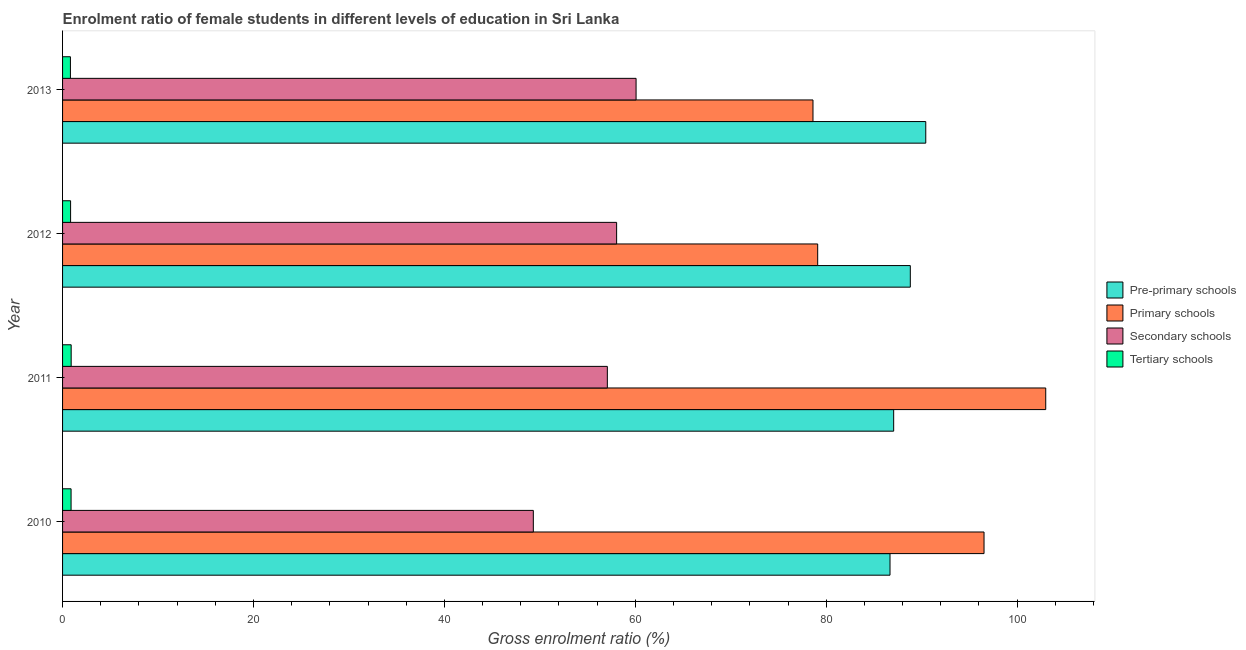Are the number of bars per tick equal to the number of legend labels?
Your answer should be very brief. Yes. How many bars are there on the 4th tick from the top?
Give a very brief answer. 4. What is the label of the 4th group of bars from the top?
Give a very brief answer. 2010. In how many cases, is the number of bars for a given year not equal to the number of legend labels?
Provide a succinct answer. 0. What is the gross enrolment ratio(male) in primary schools in 2010?
Offer a terse response. 96.53. Across all years, what is the maximum gross enrolment ratio(male) in secondary schools?
Make the answer very short. 60.08. Across all years, what is the minimum gross enrolment ratio(male) in primary schools?
Your response must be concise. 78.61. In which year was the gross enrolment ratio(male) in secondary schools maximum?
Provide a short and direct response. 2013. What is the total gross enrolment ratio(male) in primary schools in the graph?
Your response must be concise. 357.26. What is the difference between the gross enrolment ratio(male) in secondary schools in 2011 and that in 2012?
Make the answer very short. -0.97. What is the difference between the gross enrolment ratio(male) in secondary schools in 2010 and the gross enrolment ratio(male) in pre-primary schools in 2013?
Make the answer very short. -41.11. What is the average gross enrolment ratio(male) in tertiary schools per year?
Ensure brevity in your answer.  0.86. In the year 2010, what is the difference between the gross enrolment ratio(male) in tertiary schools and gross enrolment ratio(male) in pre-primary schools?
Your answer should be very brief. -85.79. What is the ratio of the gross enrolment ratio(male) in primary schools in 2010 to that in 2012?
Your answer should be very brief. 1.22. What is the difference between the highest and the second highest gross enrolment ratio(male) in tertiary schools?
Give a very brief answer. 0.01. What is the difference between the highest and the lowest gross enrolment ratio(male) in primary schools?
Keep it short and to the point. 24.38. In how many years, is the gross enrolment ratio(male) in tertiary schools greater than the average gross enrolment ratio(male) in tertiary schools taken over all years?
Offer a very short reply. 2. Is it the case that in every year, the sum of the gross enrolment ratio(male) in pre-primary schools and gross enrolment ratio(male) in tertiary schools is greater than the sum of gross enrolment ratio(male) in secondary schools and gross enrolment ratio(male) in primary schools?
Provide a short and direct response. No. What does the 2nd bar from the top in 2010 represents?
Provide a succinct answer. Secondary schools. What does the 1st bar from the bottom in 2011 represents?
Offer a very short reply. Pre-primary schools. Is it the case that in every year, the sum of the gross enrolment ratio(male) in pre-primary schools and gross enrolment ratio(male) in primary schools is greater than the gross enrolment ratio(male) in secondary schools?
Offer a terse response. Yes. What is the difference between two consecutive major ticks on the X-axis?
Give a very brief answer. 20. Does the graph contain grids?
Your response must be concise. No. Where does the legend appear in the graph?
Make the answer very short. Center right. What is the title of the graph?
Provide a succinct answer. Enrolment ratio of female students in different levels of education in Sri Lanka. Does "UNDP" appear as one of the legend labels in the graph?
Offer a very short reply. No. What is the label or title of the Y-axis?
Ensure brevity in your answer.  Year. What is the Gross enrolment ratio (%) of Pre-primary schools in 2010?
Your answer should be very brief. 86.68. What is the Gross enrolment ratio (%) of Primary schools in 2010?
Keep it short and to the point. 96.53. What is the Gross enrolment ratio (%) of Secondary schools in 2010?
Make the answer very short. 49.32. What is the Gross enrolment ratio (%) in Tertiary schools in 2010?
Offer a very short reply. 0.89. What is the Gross enrolment ratio (%) in Pre-primary schools in 2011?
Your answer should be compact. 87.07. What is the Gross enrolment ratio (%) of Primary schools in 2011?
Make the answer very short. 103. What is the Gross enrolment ratio (%) in Secondary schools in 2011?
Make the answer very short. 57.07. What is the Gross enrolment ratio (%) in Tertiary schools in 2011?
Provide a succinct answer. 0.9. What is the Gross enrolment ratio (%) in Pre-primary schools in 2012?
Your response must be concise. 88.81. What is the Gross enrolment ratio (%) of Primary schools in 2012?
Offer a terse response. 79.11. What is the Gross enrolment ratio (%) of Secondary schools in 2012?
Give a very brief answer. 58.04. What is the Gross enrolment ratio (%) in Tertiary schools in 2012?
Give a very brief answer. 0.84. What is the Gross enrolment ratio (%) of Pre-primary schools in 2013?
Provide a short and direct response. 90.43. What is the Gross enrolment ratio (%) in Primary schools in 2013?
Offer a very short reply. 78.61. What is the Gross enrolment ratio (%) of Secondary schools in 2013?
Keep it short and to the point. 60.08. What is the Gross enrolment ratio (%) of Tertiary schools in 2013?
Your answer should be compact. 0.82. Across all years, what is the maximum Gross enrolment ratio (%) of Pre-primary schools?
Ensure brevity in your answer.  90.43. Across all years, what is the maximum Gross enrolment ratio (%) in Primary schools?
Your response must be concise. 103. Across all years, what is the maximum Gross enrolment ratio (%) of Secondary schools?
Ensure brevity in your answer.  60.08. Across all years, what is the maximum Gross enrolment ratio (%) in Tertiary schools?
Offer a very short reply. 0.9. Across all years, what is the minimum Gross enrolment ratio (%) of Pre-primary schools?
Ensure brevity in your answer.  86.68. Across all years, what is the minimum Gross enrolment ratio (%) in Primary schools?
Provide a succinct answer. 78.61. Across all years, what is the minimum Gross enrolment ratio (%) in Secondary schools?
Your response must be concise. 49.32. Across all years, what is the minimum Gross enrolment ratio (%) of Tertiary schools?
Give a very brief answer. 0.82. What is the total Gross enrolment ratio (%) of Pre-primary schools in the graph?
Your answer should be compact. 352.99. What is the total Gross enrolment ratio (%) of Primary schools in the graph?
Your response must be concise. 357.25. What is the total Gross enrolment ratio (%) of Secondary schools in the graph?
Offer a terse response. 224.52. What is the total Gross enrolment ratio (%) in Tertiary schools in the graph?
Offer a terse response. 3.46. What is the difference between the Gross enrolment ratio (%) of Pre-primary schools in 2010 and that in 2011?
Offer a very short reply. -0.38. What is the difference between the Gross enrolment ratio (%) of Primary schools in 2010 and that in 2011?
Make the answer very short. -6.46. What is the difference between the Gross enrolment ratio (%) in Secondary schools in 2010 and that in 2011?
Your response must be concise. -7.75. What is the difference between the Gross enrolment ratio (%) in Tertiary schools in 2010 and that in 2011?
Offer a very short reply. -0.01. What is the difference between the Gross enrolment ratio (%) in Pre-primary schools in 2010 and that in 2012?
Your answer should be very brief. -2.13. What is the difference between the Gross enrolment ratio (%) of Primary schools in 2010 and that in 2012?
Your answer should be very brief. 17.43. What is the difference between the Gross enrolment ratio (%) in Secondary schools in 2010 and that in 2012?
Your response must be concise. -8.73. What is the difference between the Gross enrolment ratio (%) of Tertiary schools in 2010 and that in 2012?
Ensure brevity in your answer.  0.05. What is the difference between the Gross enrolment ratio (%) of Pre-primary schools in 2010 and that in 2013?
Ensure brevity in your answer.  -3.75. What is the difference between the Gross enrolment ratio (%) of Primary schools in 2010 and that in 2013?
Your response must be concise. 17.92. What is the difference between the Gross enrolment ratio (%) in Secondary schools in 2010 and that in 2013?
Make the answer very short. -10.76. What is the difference between the Gross enrolment ratio (%) in Tertiary schools in 2010 and that in 2013?
Give a very brief answer. 0.07. What is the difference between the Gross enrolment ratio (%) of Pre-primary schools in 2011 and that in 2012?
Your response must be concise. -1.74. What is the difference between the Gross enrolment ratio (%) in Primary schools in 2011 and that in 2012?
Your answer should be compact. 23.89. What is the difference between the Gross enrolment ratio (%) of Secondary schools in 2011 and that in 2012?
Ensure brevity in your answer.  -0.97. What is the difference between the Gross enrolment ratio (%) of Tertiary schools in 2011 and that in 2012?
Give a very brief answer. 0.06. What is the difference between the Gross enrolment ratio (%) in Pre-primary schools in 2011 and that in 2013?
Give a very brief answer. -3.36. What is the difference between the Gross enrolment ratio (%) in Primary schools in 2011 and that in 2013?
Make the answer very short. 24.38. What is the difference between the Gross enrolment ratio (%) in Secondary schools in 2011 and that in 2013?
Provide a short and direct response. -3.01. What is the difference between the Gross enrolment ratio (%) in Tertiary schools in 2011 and that in 2013?
Make the answer very short. 0.08. What is the difference between the Gross enrolment ratio (%) of Pre-primary schools in 2012 and that in 2013?
Offer a very short reply. -1.62. What is the difference between the Gross enrolment ratio (%) of Primary schools in 2012 and that in 2013?
Your answer should be compact. 0.49. What is the difference between the Gross enrolment ratio (%) in Secondary schools in 2012 and that in 2013?
Keep it short and to the point. -2.04. What is the difference between the Gross enrolment ratio (%) in Tertiary schools in 2012 and that in 2013?
Offer a very short reply. 0.02. What is the difference between the Gross enrolment ratio (%) in Pre-primary schools in 2010 and the Gross enrolment ratio (%) in Primary schools in 2011?
Your response must be concise. -16.31. What is the difference between the Gross enrolment ratio (%) in Pre-primary schools in 2010 and the Gross enrolment ratio (%) in Secondary schools in 2011?
Provide a short and direct response. 29.61. What is the difference between the Gross enrolment ratio (%) in Pre-primary schools in 2010 and the Gross enrolment ratio (%) in Tertiary schools in 2011?
Keep it short and to the point. 85.78. What is the difference between the Gross enrolment ratio (%) in Primary schools in 2010 and the Gross enrolment ratio (%) in Secondary schools in 2011?
Your answer should be very brief. 39.46. What is the difference between the Gross enrolment ratio (%) of Primary schools in 2010 and the Gross enrolment ratio (%) of Tertiary schools in 2011?
Make the answer very short. 95.63. What is the difference between the Gross enrolment ratio (%) of Secondary schools in 2010 and the Gross enrolment ratio (%) of Tertiary schools in 2011?
Your answer should be very brief. 48.42. What is the difference between the Gross enrolment ratio (%) in Pre-primary schools in 2010 and the Gross enrolment ratio (%) in Primary schools in 2012?
Provide a succinct answer. 7.58. What is the difference between the Gross enrolment ratio (%) in Pre-primary schools in 2010 and the Gross enrolment ratio (%) in Secondary schools in 2012?
Give a very brief answer. 28.64. What is the difference between the Gross enrolment ratio (%) in Pre-primary schools in 2010 and the Gross enrolment ratio (%) in Tertiary schools in 2012?
Your answer should be very brief. 85.84. What is the difference between the Gross enrolment ratio (%) of Primary schools in 2010 and the Gross enrolment ratio (%) of Secondary schools in 2012?
Offer a terse response. 38.49. What is the difference between the Gross enrolment ratio (%) in Primary schools in 2010 and the Gross enrolment ratio (%) in Tertiary schools in 2012?
Provide a succinct answer. 95.69. What is the difference between the Gross enrolment ratio (%) in Secondary schools in 2010 and the Gross enrolment ratio (%) in Tertiary schools in 2012?
Ensure brevity in your answer.  48.48. What is the difference between the Gross enrolment ratio (%) of Pre-primary schools in 2010 and the Gross enrolment ratio (%) of Primary schools in 2013?
Ensure brevity in your answer.  8.07. What is the difference between the Gross enrolment ratio (%) of Pre-primary schools in 2010 and the Gross enrolment ratio (%) of Secondary schools in 2013?
Ensure brevity in your answer.  26.6. What is the difference between the Gross enrolment ratio (%) in Pre-primary schools in 2010 and the Gross enrolment ratio (%) in Tertiary schools in 2013?
Provide a short and direct response. 85.86. What is the difference between the Gross enrolment ratio (%) of Primary schools in 2010 and the Gross enrolment ratio (%) of Secondary schools in 2013?
Your response must be concise. 36.45. What is the difference between the Gross enrolment ratio (%) of Primary schools in 2010 and the Gross enrolment ratio (%) of Tertiary schools in 2013?
Make the answer very short. 95.71. What is the difference between the Gross enrolment ratio (%) in Secondary schools in 2010 and the Gross enrolment ratio (%) in Tertiary schools in 2013?
Make the answer very short. 48.49. What is the difference between the Gross enrolment ratio (%) of Pre-primary schools in 2011 and the Gross enrolment ratio (%) of Primary schools in 2012?
Your response must be concise. 7.96. What is the difference between the Gross enrolment ratio (%) in Pre-primary schools in 2011 and the Gross enrolment ratio (%) in Secondary schools in 2012?
Offer a terse response. 29.02. What is the difference between the Gross enrolment ratio (%) in Pre-primary schools in 2011 and the Gross enrolment ratio (%) in Tertiary schools in 2012?
Your response must be concise. 86.23. What is the difference between the Gross enrolment ratio (%) in Primary schools in 2011 and the Gross enrolment ratio (%) in Secondary schools in 2012?
Your answer should be very brief. 44.95. What is the difference between the Gross enrolment ratio (%) in Primary schools in 2011 and the Gross enrolment ratio (%) in Tertiary schools in 2012?
Provide a succinct answer. 102.16. What is the difference between the Gross enrolment ratio (%) in Secondary schools in 2011 and the Gross enrolment ratio (%) in Tertiary schools in 2012?
Offer a terse response. 56.23. What is the difference between the Gross enrolment ratio (%) of Pre-primary schools in 2011 and the Gross enrolment ratio (%) of Primary schools in 2013?
Ensure brevity in your answer.  8.45. What is the difference between the Gross enrolment ratio (%) in Pre-primary schools in 2011 and the Gross enrolment ratio (%) in Secondary schools in 2013?
Keep it short and to the point. 26.99. What is the difference between the Gross enrolment ratio (%) in Pre-primary schools in 2011 and the Gross enrolment ratio (%) in Tertiary schools in 2013?
Make the answer very short. 86.25. What is the difference between the Gross enrolment ratio (%) in Primary schools in 2011 and the Gross enrolment ratio (%) in Secondary schools in 2013?
Offer a very short reply. 42.92. What is the difference between the Gross enrolment ratio (%) in Primary schools in 2011 and the Gross enrolment ratio (%) in Tertiary schools in 2013?
Give a very brief answer. 102.18. What is the difference between the Gross enrolment ratio (%) in Secondary schools in 2011 and the Gross enrolment ratio (%) in Tertiary schools in 2013?
Provide a short and direct response. 56.25. What is the difference between the Gross enrolment ratio (%) in Pre-primary schools in 2012 and the Gross enrolment ratio (%) in Primary schools in 2013?
Offer a very short reply. 10.2. What is the difference between the Gross enrolment ratio (%) in Pre-primary schools in 2012 and the Gross enrolment ratio (%) in Secondary schools in 2013?
Make the answer very short. 28.73. What is the difference between the Gross enrolment ratio (%) in Pre-primary schools in 2012 and the Gross enrolment ratio (%) in Tertiary schools in 2013?
Provide a short and direct response. 87.99. What is the difference between the Gross enrolment ratio (%) in Primary schools in 2012 and the Gross enrolment ratio (%) in Secondary schools in 2013?
Provide a short and direct response. 19.03. What is the difference between the Gross enrolment ratio (%) of Primary schools in 2012 and the Gross enrolment ratio (%) of Tertiary schools in 2013?
Offer a very short reply. 78.29. What is the difference between the Gross enrolment ratio (%) in Secondary schools in 2012 and the Gross enrolment ratio (%) in Tertiary schools in 2013?
Your answer should be very brief. 57.22. What is the average Gross enrolment ratio (%) of Pre-primary schools per year?
Ensure brevity in your answer.  88.25. What is the average Gross enrolment ratio (%) in Primary schools per year?
Offer a very short reply. 89.31. What is the average Gross enrolment ratio (%) in Secondary schools per year?
Provide a short and direct response. 56.13. What is the average Gross enrolment ratio (%) of Tertiary schools per year?
Ensure brevity in your answer.  0.86. In the year 2010, what is the difference between the Gross enrolment ratio (%) of Pre-primary schools and Gross enrolment ratio (%) of Primary schools?
Your answer should be compact. -9.85. In the year 2010, what is the difference between the Gross enrolment ratio (%) in Pre-primary schools and Gross enrolment ratio (%) in Secondary schools?
Give a very brief answer. 37.37. In the year 2010, what is the difference between the Gross enrolment ratio (%) in Pre-primary schools and Gross enrolment ratio (%) in Tertiary schools?
Give a very brief answer. 85.79. In the year 2010, what is the difference between the Gross enrolment ratio (%) of Primary schools and Gross enrolment ratio (%) of Secondary schools?
Your answer should be compact. 47.22. In the year 2010, what is the difference between the Gross enrolment ratio (%) of Primary schools and Gross enrolment ratio (%) of Tertiary schools?
Provide a succinct answer. 95.64. In the year 2010, what is the difference between the Gross enrolment ratio (%) of Secondary schools and Gross enrolment ratio (%) of Tertiary schools?
Give a very brief answer. 48.43. In the year 2011, what is the difference between the Gross enrolment ratio (%) of Pre-primary schools and Gross enrolment ratio (%) of Primary schools?
Offer a terse response. -15.93. In the year 2011, what is the difference between the Gross enrolment ratio (%) of Pre-primary schools and Gross enrolment ratio (%) of Secondary schools?
Ensure brevity in your answer.  30. In the year 2011, what is the difference between the Gross enrolment ratio (%) of Pre-primary schools and Gross enrolment ratio (%) of Tertiary schools?
Provide a succinct answer. 86.17. In the year 2011, what is the difference between the Gross enrolment ratio (%) in Primary schools and Gross enrolment ratio (%) in Secondary schools?
Provide a short and direct response. 45.93. In the year 2011, what is the difference between the Gross enrolment ratio (%) in Primary schools and Gross enrolment ratio (%) in Tertiary schools?
Give a very brief answer. 102.1. In the year 2011, what is the difference between the Gross enrolment ratio (%) of Secondary schools and Gross enrolment ratio (%) of Tertiary schools?
Provide a succinct answer. 56.17. In the year 2012, what is the difference between the Gross enrolment ratio (%) of Pre-primary schools and Gross enrolment ratio (%) of Primary schools?
Your answer should be very brief. 9.7. In the year 2012, what is the difference between the Gross enrolment ratio (%) of Pre-primary schools and Gross enrolment ratio (%) of Secondary schools?
Ensure brevity in your answer.  30.77. In the year 2012, what is the difference between the Gross enrolment ratio (%) in Pre-primary schools and Gross enrolment ratio (%) in Tertiary schools?
Provide a short and direct response. 87.97. In the year 2012, what is the difference between the Gross enrolment ratio (%) in Primary schools and Gross enrolment ratio (%) in Secondary schools?
Your response must be concise. 21.06. In the year 2012, what is the difference between the Gross enrolment ratio (%) of Primary schools and Gross enrolment ratio (%) of Tertiary schools?
Your answer should be very brief. 78.27. In the year 2012, what is the difference between the Gross enrolment ratio (%) of Secondary schools and Gross enrolment ratio (%) of Tertiary schools?
Make the answer very short. 57.2. In the year 2013, what is the difference between the Gross enrolment ratio (%) in Pre-primary schools and Gross enrolment ratio (%) in Primary schools?
Offer a terse response. 11.82. In the year 2013, what is the difference between the Gross enrolment ratio (%) in Pre-primary schools and Gross enrolment ratio (%) in Secondary schools?
Your answer should be very brief. 30.35. In the year 2013, what is the difference between the Gross enrolment ratio (%) in Pre-primary schools and Gross enrolment ratio (%) in Tertiary schools?
Keep it short and to the point. 89.61. In the year 2013, what is the difference between the Gross enrolment ratio (%) of Primary schools and Gross enrolment ratio (%) of Secondary schools?
Your answer should be compact. 18.53. In the year 2013, what is the difference between the Gross enrolment ratio (%) in Primary schools and Gross enrolment ratio (%) in Tertiary schools?
Provide a short and direct response. 77.79. In the year 2013, what is the difference between the Gross enrolment ratio (%) of Secondary schools and Gross enrolment ratio (%) of Tertiary schools?
Give a very brief answer. 59.26. What is the ratio of the Gross enrolment ratio (%) of Pre-primary schools in 2010 to that in 2011?
Your response must be concise. 1. What is the ratio of the Gross enrolment ratio (%) of Primary schools in 2010 to that in 2011?
Offer a terse response. 0.94. What is the ratio of the Gross enrolment ratio (%) in Secondary schools in 2010 to that in 2011?
Provide a short and direct response. 0.86. What is the ratio of the Gross enrolment ratio (%) in Tertiary schools in 2010 to that in 2011?
Offer a terse response. 0.99. What is the ratio of the Gross enrolment ratio (%) in Pre-primary schools in 2010 to that in 2012?
Provide a short and direct response. 0.98. What is the ratio of the Gross enrolment ratio (%) in Primary schools in 2010 to that in 2012?
Offer a very short reply. 1.22. What is the ratio of the Gross enrolment ratio (%) of Secondary schools in 2010 to that in 2012?
Your answer should be compact. 0.85. What is the ratio of the Gross enrolment ratio (%) of Tertiary schools in 2010 to that in 2012?
Your response must be concise. 1.06. What is the ratio of the Gross enrolment ratio (%) of Pre-primary schools in 2010 to that in 2013?
Provide a short and direct response. 0.96. What is the ratio of the Gross enrolment ratio (%) of Primary schools in 2010 to that in 2013?
Your answer should be very brief. 1.23. What is the ratio of the Gross enrolment ratio (%) in Secondary schools in 2010 to that in 2013?
Ensure brevity in your answer.  0.82. What is the ratio of the Gross enrolment ratio (%) in Tertiary schools in 2010 to that in 2013?
Make the answer very short. 1.08. What is the ratio of the Gross enrolment ratio (%) in Pre-primary schools in 2011 to that in 2012?
Your answer should be very brief. 0.98. What is the ratio of the Gross enrolment ratio (%) of Primary schools in 2011 to that in 2012?
Keep it short and to the point. 1.3. What is the ratio of the Gross enrolment ratio (%) in Secondary schools in 2011 to that in 2012?
Make the answer very short. 0.98. What is the ratio of the Gross enrolment ratio (%) in Tertiary schools in 2011 to that in 2012?
Provide a succinct answer. 1.07. What is the ratio of the Gross enrolment ratio (%) of Pre-primary schools in 2011 to that in 2013?
Make the answer very short. 0.96. What is the ratio of the Gross enrolment ratio (%) in Primary schools in 2011 to that in 2013?
Offer a very short reply. 1.31. What is the ratio of the Gross enrolment ratio (%) in Secondary schools in 2011 to that in 2013?
Provide a short and direct response. 0.95. What is the ratio of the Gross enrolment ratio (%) in Tertiary schools in 2011 to that in 2013?
Keep it short and to the point. 1.1. What is the ratio of the Gross enrolment ratio (%) of Pre-primary schools in 2012 to that in 2013?
Give a very brief answer. 0.98. What is the ratio of the Gross enrolment ratio (%) in Primary schools in 2012 to that in 2013?
Your response must be concise. 1.01. What is the ratio of the Gross enrolment ratio (%) of Secondary schools in 2012 to that in 2013?
Give a very brief answer. 0.97. What is the ratio of the Gross enrolment ratio (%) in Tertiary schools in 2012 to that in 2013?
Make the answer very short. 1.02. What is the difference between the highest and the second highest Gross enrolment ratio (%) of Pre-primary schools?
Provide a succinct answer. 1.62. What is the difference between the highest and the second highest Gross enrolment ratio (%) in Primary schools?
Ensure brevity in your answer.  6.46. What is the difference between the highest and the second highest Gross enrolment ratio (%) in Secondary schools?
Offer a very short reply. 2.04. What is the difference between the highest and the second highest Gross enrolment ratio (%) in Tertiary schools?
Keep it short and to the point. 0.01. What is the difference between the highest and the lowest Gross enrolment ratio (%) of Pre-primary schools?
Provide a short and direct response. 3.75. What is the difference between the highest and the lowest Gross enrolment ratio (%) of Primary schools?
Your answer should be very brief. 24.38. What is the difference between the highest and the lowest Gross enrolment ratio (%) of Secondary schools?
Offer a very short reply. 10.76. What is the difference between the highest and the lowest Gross enrolment ratio (%) in Tertiary schools?
Ensure brevity in your answer.  0.08. 